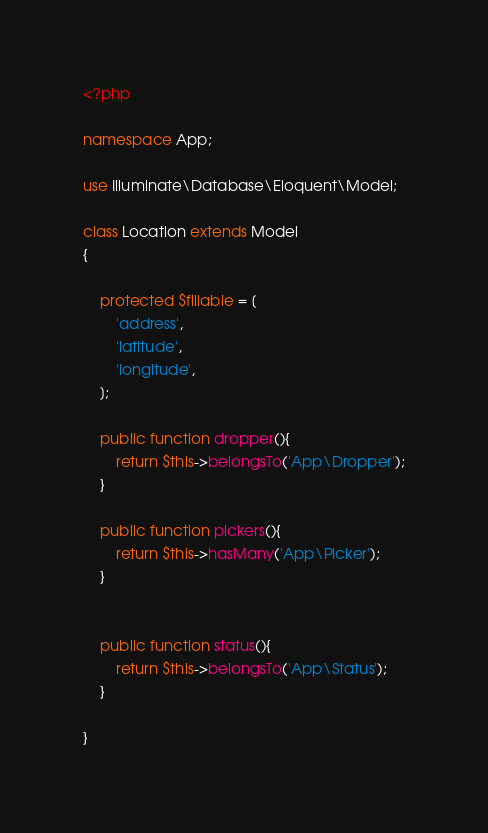<code> <loc_0><loc_0><loc_500><loc_500><_PHP_><?php

namespace App;

use Illuminate\Database\Eloquent\Model;

class Location extends Model
{

    protected $fillable = [
        'address',
        'latitude',
        'longitude',
    ];

    public function dropper(){
        return $this->belongsTo('App\Dropper');
    }

    public function pickers(){
        return $this->hasMany('App\Picker');
    }
    

    public function status(){
        return $this->belongsTo('App\Status');
    }

}
</code> 